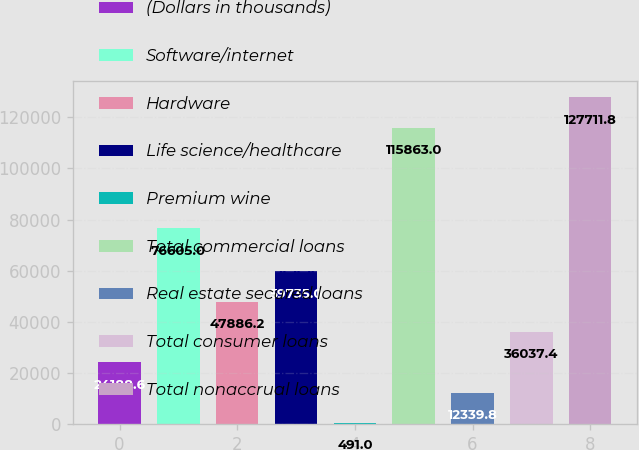<chart> <loc_0><loc_0><loc_500><loc_500><bar_chart><fcel>(Dollars in thousands)<fcel>Software/internet<fcel>Hardware<fcel>Life science/healthcare<fcel>Premium wine<fcel>Total commercial loans<fcel>Real estate secured loans<fcel>Total consumer loans<fcel>Total nonaccrual loans<nl><fcel>24188.6<fcel>76605<fcel>47886.2<fcel>59735<fcel>491<fcel>115863<fcel>12339.8<fcel>36037.4<fcel>127712<nl></chart> 